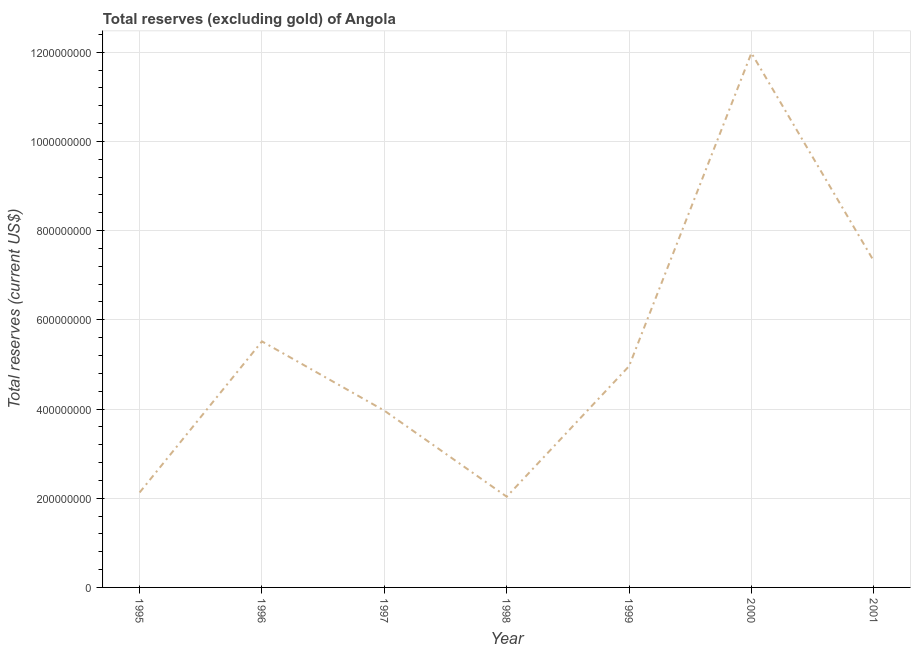What is the total reserves (excluding gold) in 1995?
Give a very brief answer. 2.13e+08. Across all years, what is the maximum total reserves (excluding gold)?
Provide a short and direct response. 1.20e+09. Across all years, what is the minimum total reserves (excluding gold)?
Provide a short and direct response. 2.03e+08. In which year was the total reserves (excluding gold) maximum?
Provide a short and direct response. 2000. What is the sum of the total reserves (excluding gold)?
Your answer should be compact. 3.79e+09. What is the difference between the total reserves (excluding gold) in 1995 and 1996?
Offer a terse response. -3.39e+08. What is the average total reserves (excluding gold) per year?
Make the answer very short. 5.42e+08. What is the median total reserves (excluding gold)?
Give a very brief answer. 4.96e+08. What is the ratio of the total reserves (excluding gold) in 1995 to that in 2001?
Offer a terse response. 0.29. What is the difference between the highest and the second highest total reserves (excluding gold)?
Offer a very short reply. 4.66e+08. Is the sum of the total reserves (excluding gold) in 1999 and 2000 greater than the maximum total reserves (excluding gold) across all years?
Make the answer very short. Yes. What is the difference between the highest and the lowest total reserves (excluding gold)?
Offer a very short reply. 9.95e+08. Does the total reserves (excluding gold) monotonically increase over the years?
Offer a terse response. No. How many lines are there?
Keep it short and to the point. 1. How many years are there in the graph?
Make the answer very short. 7. What is the difference between two consecutive major ticks on the Y-axis?
Your response must be concise. 2.00e+08. Are the values on the major ticks of Y-axis written in scientific E-notation?
Provide a succinct answer. No. Does the graph contain grids?
Your response must be concise. Yes. What is the title of the graph?
Give a very brief answer. Total reserves (excluding gold) of Angola. What is the label or title of the Y-axis?
Make the answer very short. Total reserves (current US$). What is the Total reserves (current US$) in 1995?
Offer a terse response. 2.13e+08. What is the Total reserves (current US$) in 1996?
Offer a very short reply. 5.52e+08. What is the Total reserves (current US$) in 1997?
Give a very brief answer. 3.96e+08. What is the Total reserves (current US$) in 1998?
Your answer should be compact. 2.03e+08. What is the Total reserves (current US$) in 1999?
Offer a terse response. 4.96e+08. What is the Total reserves (current US$) in 2000?
Your answer should be very brief. 1.20e+09. What is the Total reserves (current US$) of 2001?
Provide a short and direct response. 7.32e+08. What is the difference between the Total reserves (current US$) in 1995 and 1996?
Your answer should be compact. -3.39e+08. What is the difference between the Total reserves (current US$) in 1995 and 1997?
Offer a very short reply. -1.84e+08. What is the difference between the Total reserves (current US$) in 1995 and 1998?
Provide a short and direct response. 9.38e+06. What is the difference between the Total reserves (current US$) in 1995 and 1999?
Your answer should be very brief. -2.83e+08. What is the difference between the Total reserves (current US$) in 1995 and 2000?
Offer a very short reply. -9.85e+08. What is the difference between the Total reserves (current US$) in 1995 and 2001?
Provide a succinct answer. -5.19e+08. What is the difference between the Total reserves (current US$) in 1996 and 1997?
Provide a short and direct response. 1.55e+08. What is the difference between the Total reserves (current US$) in 1996 and 1998?
Your answer should be compact. 3.48e+08. What is the difference between the Total reserves (current US$) in 1996 and 1999?
Your response must be concise. 5.55e+07. What is the difference between the Total reserves (current US$) in 1996 and 2000?
Your answer should be very brief. -6.47e+08. What is the difference between the Total reserves (current US$) in 1996 and 2001?
Make the answer very short. -1.80e+08. What is the difference between the Total reserves (current US$) in 1997 and 1998?
Make the answer very short. 1.93e+08. What is the difference between the Total reserves (current US$) in 1997 and 1999?
Your response must be concise. -9.97e+07. What is the difference between the Total reserves (current US$) in 1997 and 2000?
Your response must be concise. -8.02e+08. What is the difference between the Total reserves (current US$) in 1997 and 2001?
Provide a succinct answer. -3.35e+08. What is the difference between the Total reserves (current US$) in 1998 and 1999?
Make the answer very short. -2.93e+08. What is the difference between the Total reserves (current US$) in 1998 and 2000?
Your answer should be very brief. -9.95e+08. What is the difference between the Total reserves (current US$) in 1998 and 2001?
Keep it short and to the point. -5.28e+08. What is the difference between the Total reserves (current US$) in 1999 and 2000?
Give a very brief answer. -7.02e+08. What is the difference between the Total reserves (current US$) in 1999 and 2001?
Your answer should be compact. -2.36e+08. What is the difference between the Total reserves (current US$) in 2000 and 2001?
Keep it short and to the point. 4.66e+08. What is the ratio of the Total reserves (current US$) in 1995 to that in 1996?
Make the answer very short. 0.39. What is the ratio of the Total reserves (current US$) in 1995 to that in 1997?
Ensure brevity in your answer.  0.54. What is the ratio of the Total reserves (current US$) in 1995 to that in 1998?
Offer a very short reply. 1.05. What is the ratio of the Total reserves (current US$) in 1995 to that in 1999?
Offer a terse response. 0.43. What is the ratio of the Total reserves (current US$) in 1995 to that in 2000?
Your response must be concise. 0.18. What is the ratio of the Total reserves (current US$) in 1995 to that in 2001?
Your response must be concise. 0.29. What is the ratio of the Total reserves (current US$) in 1996 to that in 1997?
Your answer should be very brief. 1.39. What is the ratio of the Total reserves (current US$) in 1996 to that in 1998?
Keep it short and to the point. 2.71. What is the ratio of the Total reserves (current US$) in 1996 to that in 1999?
Ensure brevity in your answer.  1.11. What is the ratio of the Total reserves (current US$) in 1996 to that in 2000?
Provide a succinct answer. 0.46. What is the ratio of the Total reserves (current US$) in 1996 to that in 2001?
Your answer should be very brief. 0.75. What is the ratio of the Total reserves (current US$) in 1997 to that in 1998?
Your response must be concise. 1.95. What is the ratio of the Total reserves (current US$) in 1997 to that in 1999?
Give a very brief answer. 0.8. What is the ratio of the Total reserves (current US$) in 1997 to that in 2000?
Your response must be concise. 0.33. What is the ratio of the Total reserves (current US$) in 1997 to that in 2001?
Make the answer very short. 0.54. What is the ratio of the Total reserves (current US$) in 1998 to that in 1999?
Your answer should be compact. 0.41. What is the ratio of the Total reserves (current US$) in 1998 to that in 2000?
Give a very brief answer. 0.17. What is the ratio of the Total reserves (current US$) in 1998 to that in 2001?
Keep it short and to the point. 0.28. What is the ratio of the Total reserves (current US$) in 1999 to that in 2000?
Offer a very short reply. 0.41. What is the ratio of the Total reserves (current US$) in 1999 to that in 2001?
Your response must be concise. 0.68. What is the ratio of the Total reserves (current US$) in 2000 to that in 2001?
Provide a short and direct response. 1.64. 